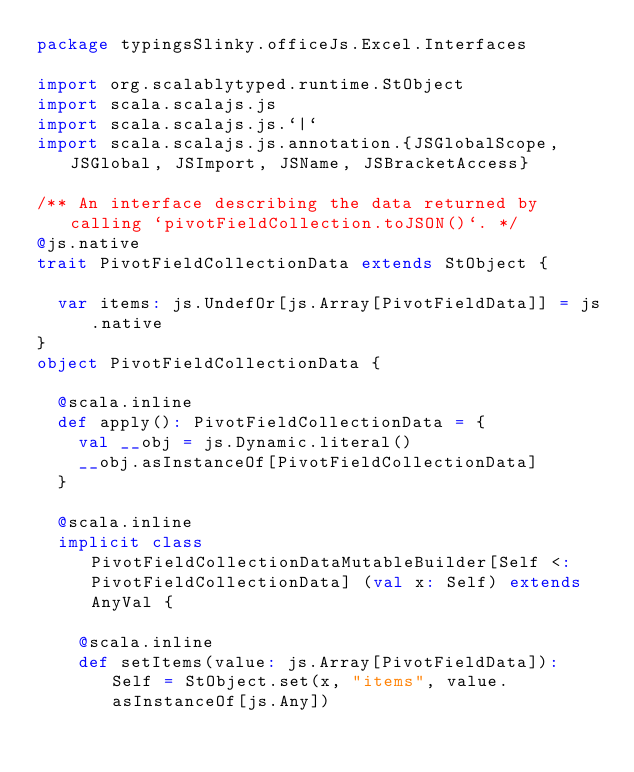<code> <loc_0><loc_0><loc_500><loc_500><_Scala_>package typingsSlinky.officeJs.Excel.Interfaces

import org.scalablytyped.runtime.StObject
import scala.scalajs.js
import scala.scalajs.js.`|`
import scala.scalajs.js.annotation.{JSGlobalScope, JSGlobal, JSImport, JSName, JSBracketAccess}

/** An interface describing the data returned by calling `pivotFieldCollection.toJSON()`. */
@js.native
trait PivotFieldCollectionData extends StObject {
  
  var items: js.UndefOr[js.Array[PivotFieldData]] = js.native
}
object PivotFieldCollectionData {
  
  @scala.inline
  def apply(): PivotFieldCollectionData = {
    val __obj = js.Dynamic.literal()
    __obj.asInstanceOf[PivotFieldCollectionData]
  }
  
  @scala.inline
  implicit class PivotFieldCollectionDataMutableBuilder[Self <: PivotFieldCollectionData] (val x: Self) extends AnyVal {
    
    @scala.inline
    def setItems(value: js.Array[PivotFieldData]): Self = StObject.set(x, "items", value.asInstanceOf[js.Any])
    </code> 